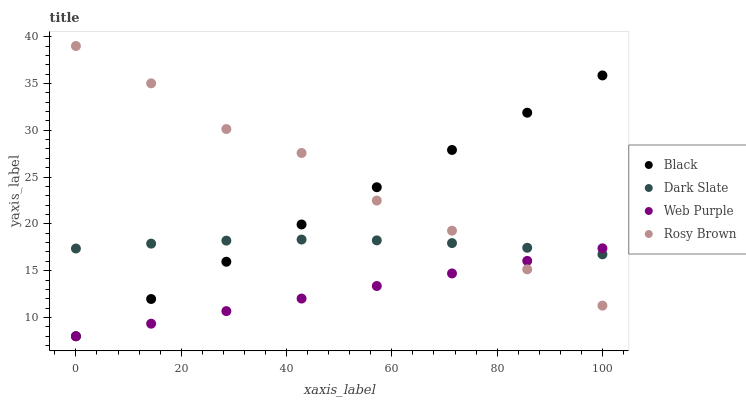Does Web Purple have the minimum area under the curve?
Answer yes or no. Yes. Does Rosy Brown have the maximum area under the curve?
Answer yes or no. Yes. Does Rosy Brown have the minimum area under the curve?
Answer yes or no. No. Does Web Purple have the maximum area under the curve?
Answer yes or no. No. Is Web Purple the smoothest?
Answer yes or no. Yes. Is Rosy Brown the roughest?
Answer yes or no. Yes. Is Rosy Brown the smoothest?
Answer yes or no. No. Is Web Purple the roughest?
Answer yes or no. No. Does Web Purple have the lowest value?
Answer yes or no. Yes. Does Rosy Brown have the lowest value?
Answer yes or no. No. Does Rosy Brown have the highest value?
Answer yes or no. Yes. Does Web Purple have the highest value?
Answer yes or no. No. Does Dark Slate intersect Rosy Brown?
Answer yes or no. Yes. Is Dark Slate less than Rosy Brown?
Answer yes or no. No. Is Dark Slate greater than Rosy Brown?
Answer yes or no. No. 